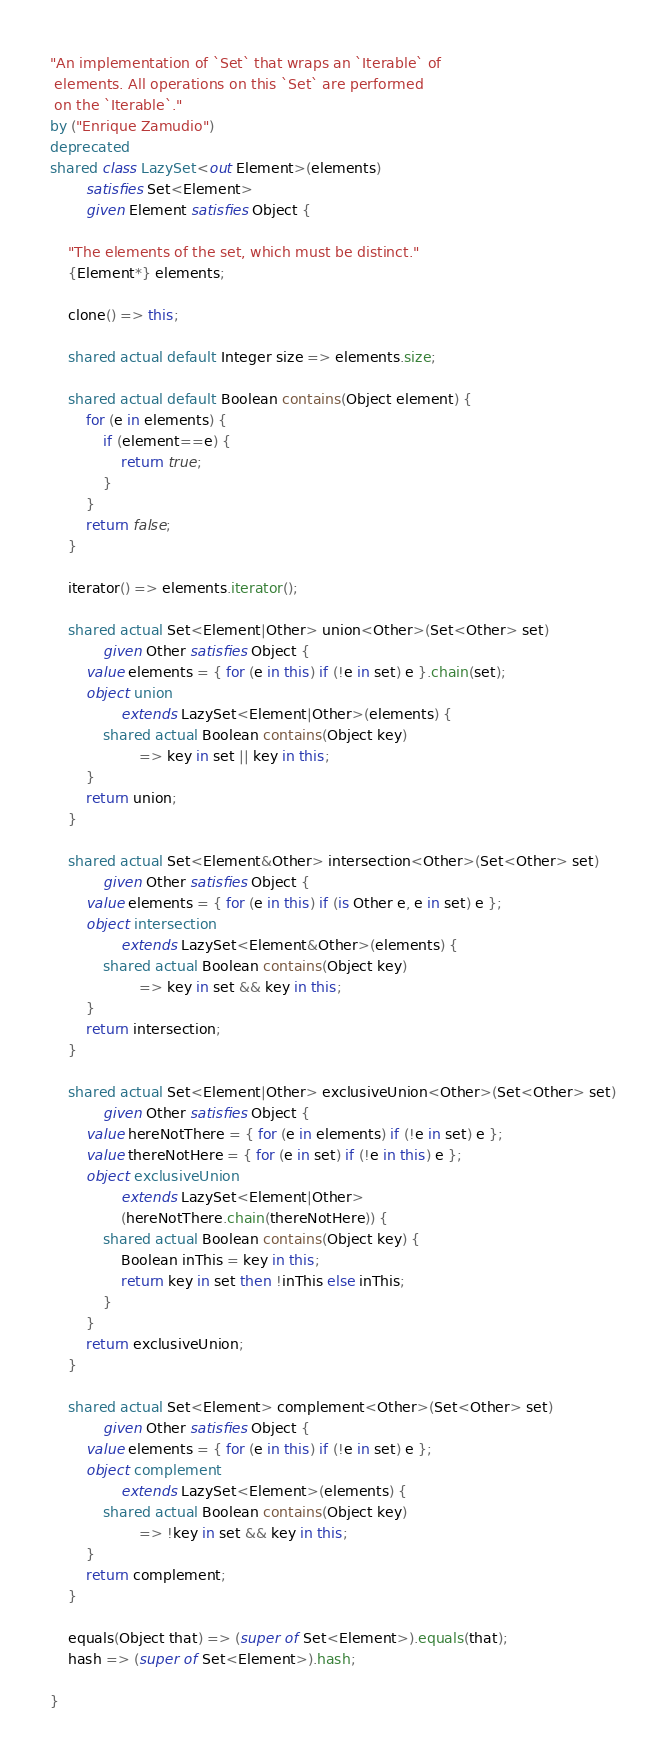Convert code to text. <code><loc_0><loc_0><loc_500><loc_500><_Ceylon_>"An implementation of `Set` that wraps an `Iterable` of
 elements. All operations on this `Set` are performed
 on the `Iterable`."
by ("Enrique Zamudio")
deprecated
shared class LazySet<out Element>(elements)
        satisfies Set<Element>
        given Element satisfies Object {
    
    "The elements of the set, which must be distinct."
    {Element*} elements;
    
    clone() => this;
    
    shared actual default Integer size => elements.size;
    
    shared actual default Boolean contains(Object element) {
        for (e in elements) {
            if (element==e) {
                return true;
            }
        }
        return false;
    }
    
    iterator() => elements.iterator();
    
    shared actual Set<Element|Other> union<Other>(Set<Other> set)
            given Other satisfies Object {
        value elements = { for (e in this) if (!e in set) e }.chain(set);
        object union 
                extends LazySet<Element|Other>(elements) {
            shared actual Boolean contains(Object key) 
                    => key in set || key in this;
        }
        return union;
    }
    
    shared actual Set<Element&Other> intersection<Other>(Set<Other> set)
            given Other satisfies Object {
        value elements = { for (e in this) if (is Other e, e in set) e };
        object intersection 
                extends LazySet<Element&Other>(elements) {
            shared actual Boolean contains(Object key) 
                    => key in set && key in this;
        }
        return intersection;
    }
    
    shared actual Set<Element|Other> exclusiveUnion<Other>(Set<Other> set)
            given Other satisfies Object {
        value hereNotThere = { for (e in elements) if (!e in set) e };
        value thereNotHere = { for (e in set) if (!e in this) e };
        object exclusiveUnion 
                extends LazySet<Element|Other>
                (hereNotThere.chain(thereNotHere)) {
            shared actual Boolean contains(Object key) {
                Boolean inThis = key in this;
                return key in set then !inThis else inThis;
            }
        }
        return exclusiveUnion;
    }
    
    shared actual Set<Element> complement<Other>(Set<Other> set)
            given Other satisfies Object {
        value elements = { for (e in this) if (!e in set) e };
        object complement 
                extends LazySet<Element>(elements) {
            shared actual Boolean contains(Object key) 
                    => !key in set && key in this;
        }
        return complement;
    }
    
    equals(Object that) => (super of Set<Element>).equals(that);
    hash => (super of Set<Element>).hash;
    
}

</code> 